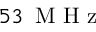<formula> <loc_0><loc_0><loc_500><loc_500>5 3 { \, M H z }</formula> 